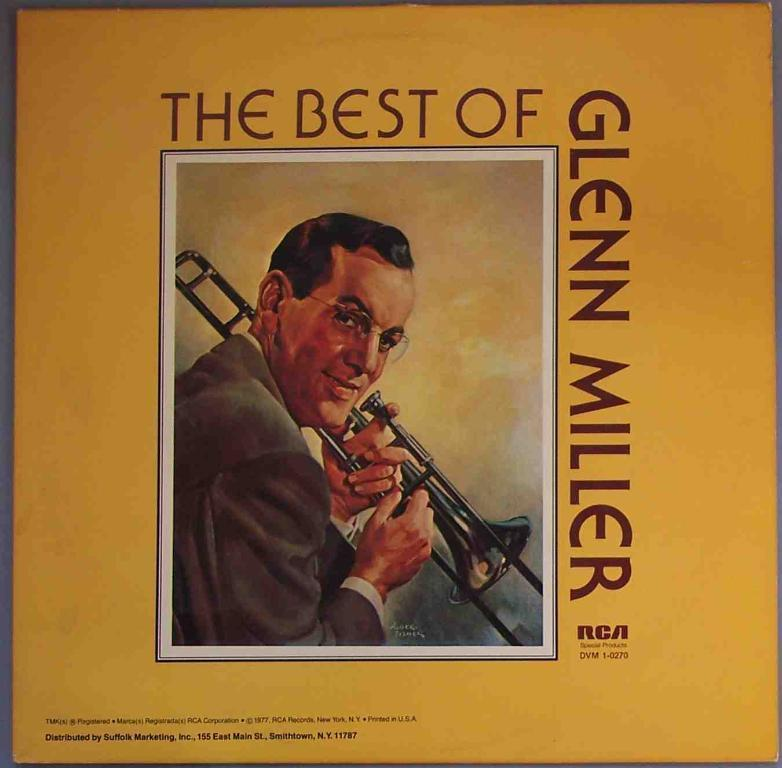What is the main subject of the image? The main subject of the image is a poster. What is depicted on the poster? There is a person playing a musical instrument in the center of the poster. Are there any words on the poster? Yes, there is text on the poster. What color is the poster? The poster is yellow in color. Can you see any fangs on the person playing the musical instrument in the image? There are no fangs visible on the person playing the musical instrument in the image. What type of stove is shown in the image? There is no stove present in the image; it features a poster with a person playing a musical instrument. 